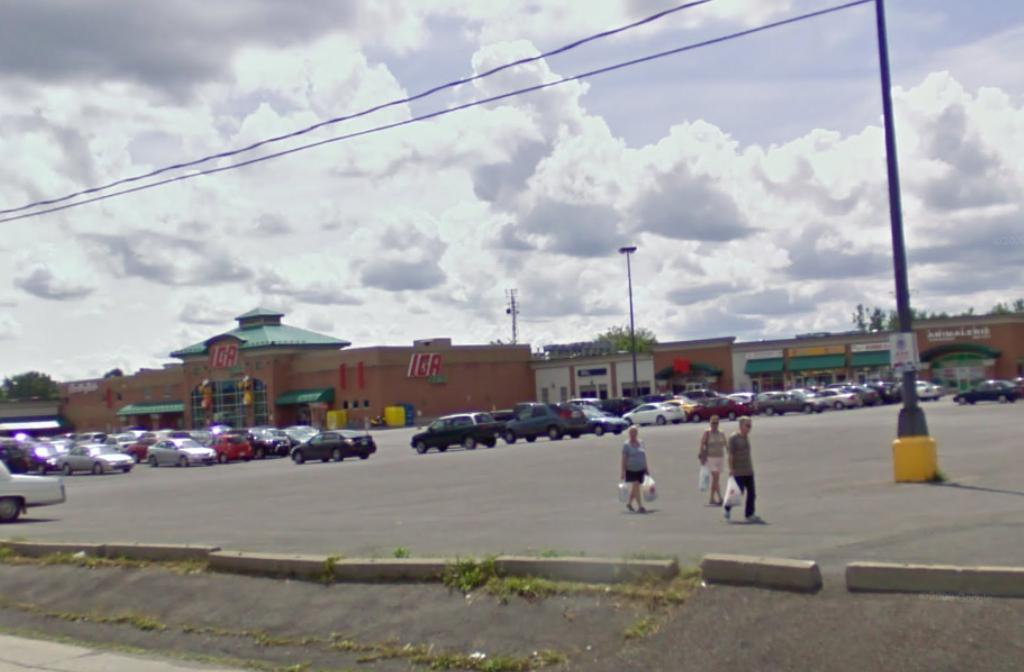Provide a one-sentence caption for the provided image. Several cars are parked outside a store called IGA. 